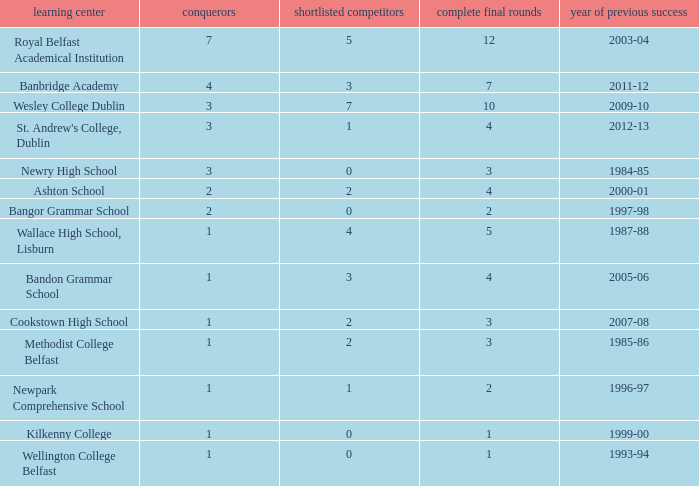What is the name of the school where the year of last win is 1985-86? Methodist College Belfast. 